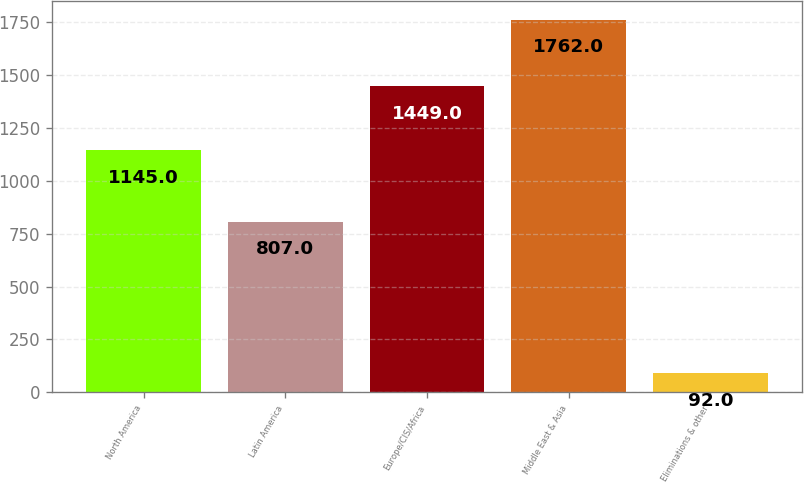Convert chart to OTSL. <chart><loc_0><loc_0><loc_500><loc_500><bar_chart><fcel>North America<fcel>Latin America<fcel>Europe/CIS/Africa<fcel>Middle East & Asia<fcel>Eliminations & other<nl><fcel>1145<fcel>807<fcel>1449<fcel>1762<fcel>92<nl></chart> 